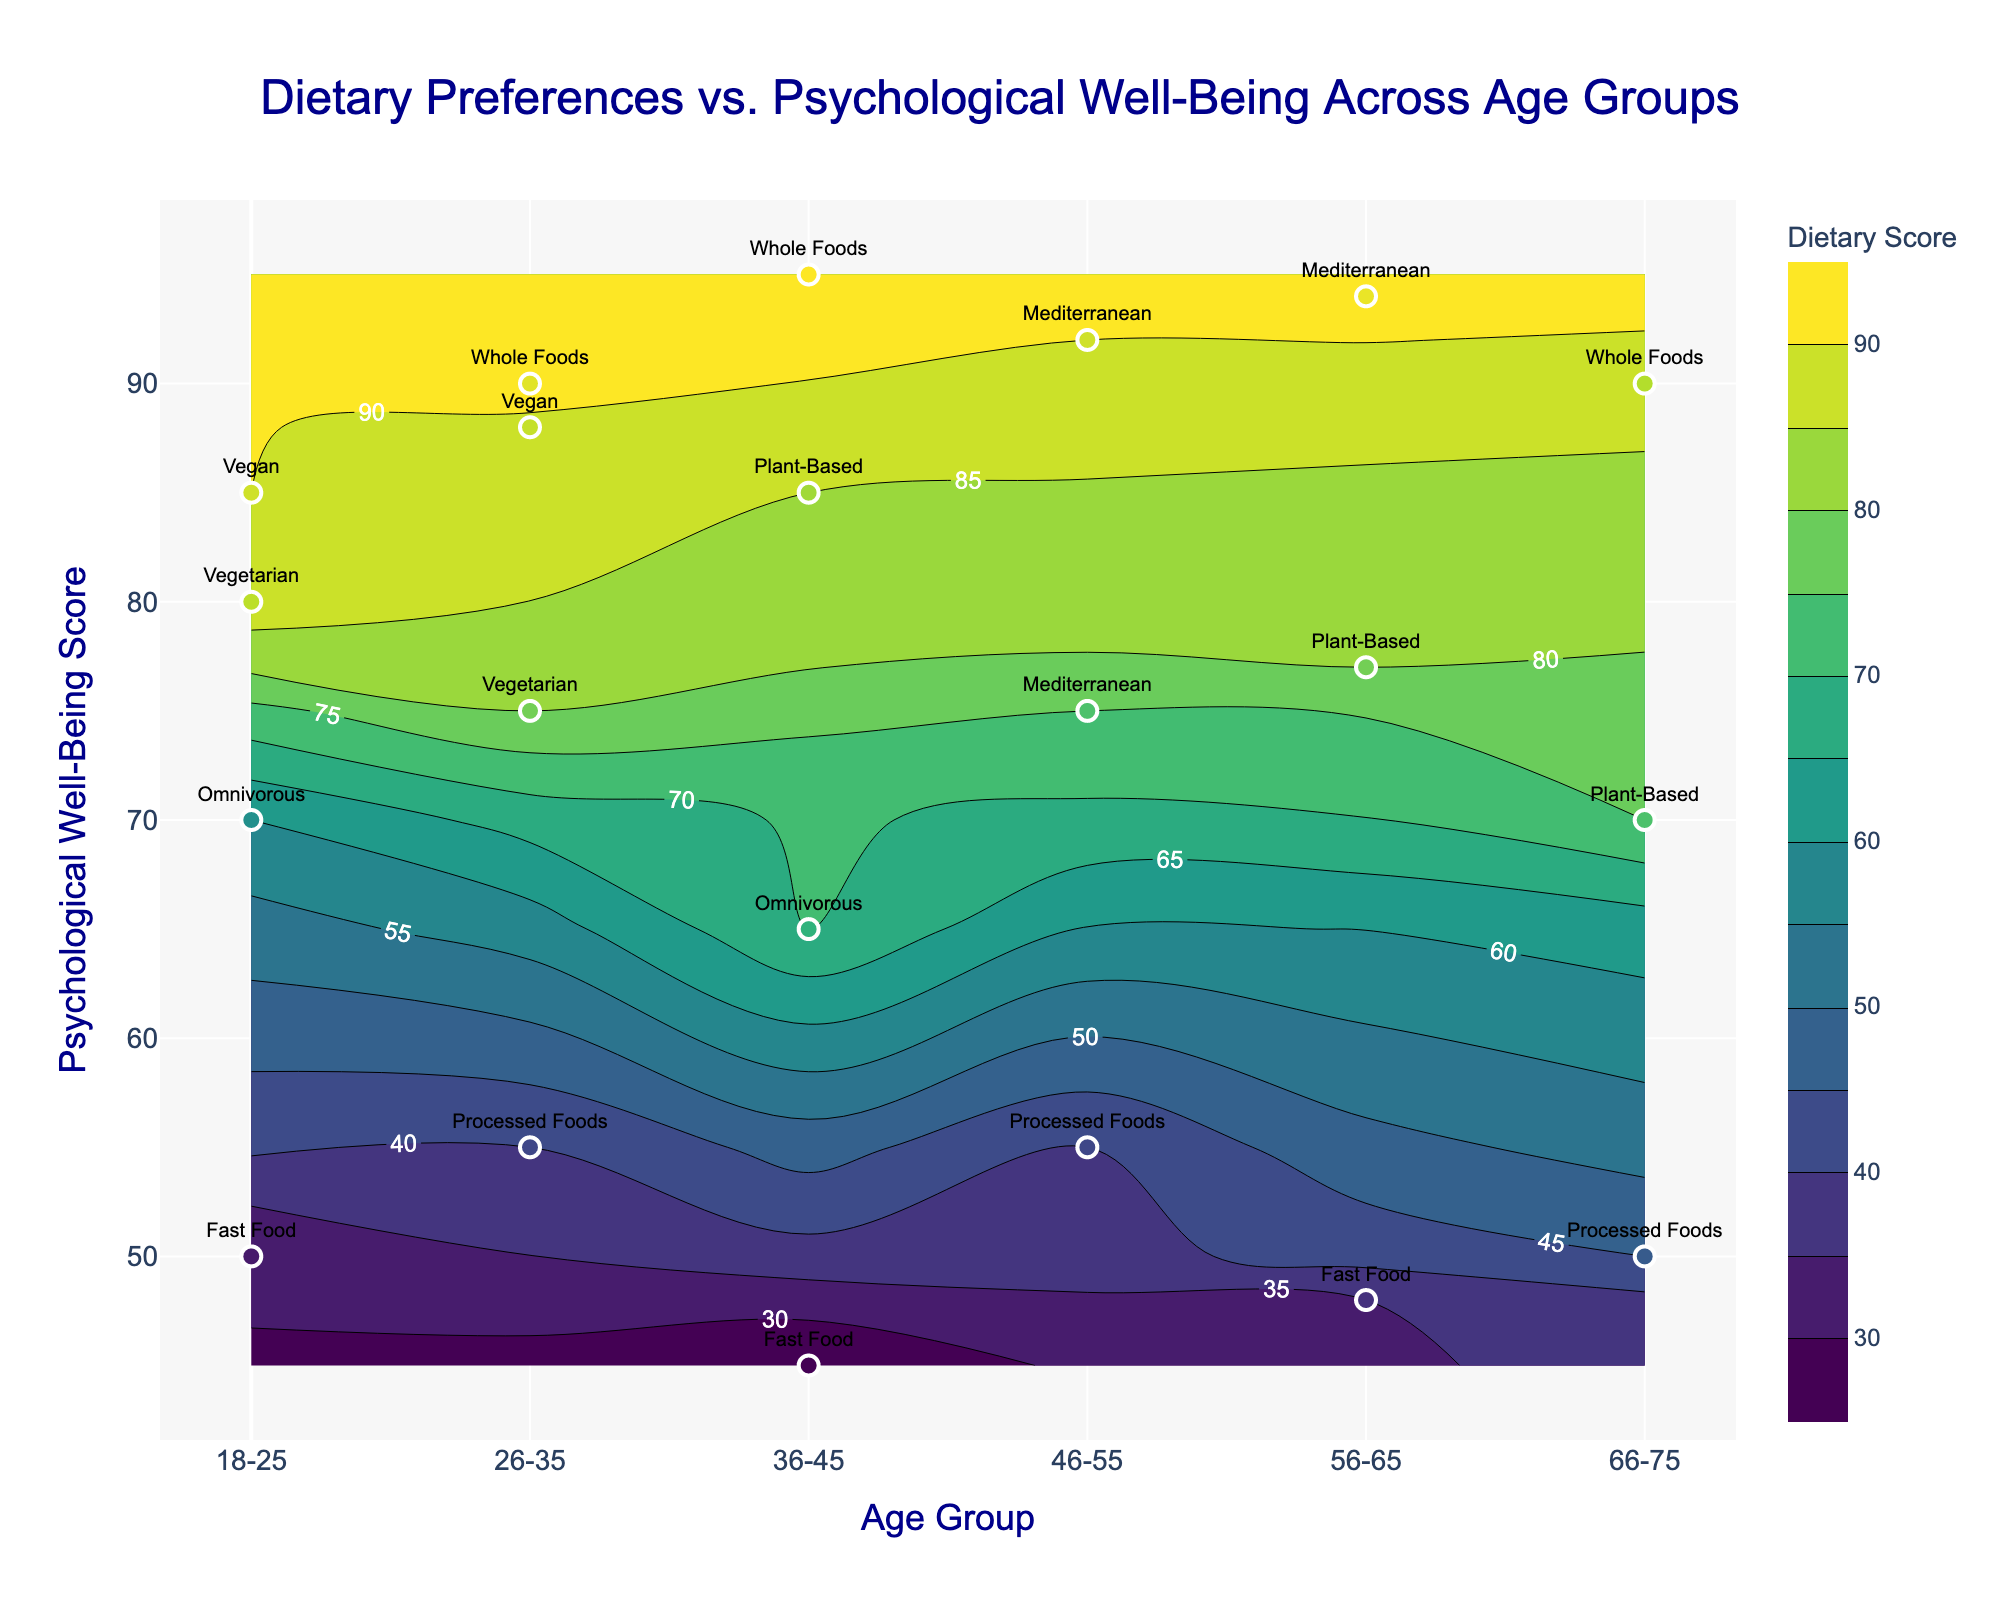What is the title of the plot? The title is visible at the top of the plot and can be directly read from there.
Answer: Dietary Preferences vs. Psychological Well-Being Across Age Groups What are the age groups presented on the x-axis? The x-axis shows categorical labels for age groups. By looking at the tick labels, you can see all the age groups displayed.
Answer: 18-25, 26-35, 36-45, 46-55, 56-65, 66-75 Which dietary preference has the highest "Well-Being Score" for the age group "18-25"? Locate the scatter points for the age group "18-25" on the plot and look for the point with the highest y-coordinate (Well-Being Score). The dietary preference label next to this point is the answer.
Answer: Vegan For the age group "36-45", what is the difference in "Well-Being Score" between those preferring Whole Foods and Fast Food? Identify the y-coordinates (Well-Being Scores) of the dietary preferences Whole Foods and Fast Food for the age group "36-45" and calculate their difference.
Answer: 95 - 45 = 50 Which age group has the highest average Dietary Score? To determine the average Dietary Score for each age group, first sum up the Dietary Scores for each age group, then divide by the number of dietary preferences in that group. Compare these averages across all age groups.
Answer: 56-65 How many dietary preferences are listed for the age group "46-55"? Count the number of scatter points labeled with dietary preferences within the age group "46-55" on the x-axis.
Answer: 3 Is there an age group where a high psychological well-being score correlates with a low dietary score? Scan the plot for points where a high y-coordinate (Well-Being Score) corresponds to a low color intensity (Dietary Score) within a single age group.
Answer: No Which age group has the widest range in "Well-Being Score"? Find the range by subtracting the minimum Well-Being Score from the maximum Well-Being Score for each age group, then identify the age group with the largest result.
Answer: 18-25 Do “Mediterranean” and “Processed Foods” dietary preferences co-occur within any age group? Check each age group for the presence of both “Mediterranean” and “Processed Foods” labels among the scatter points.
Answer: Yes, in age group 46-55 What is the general trend of dietary scores as age groups progress? Observe the contour lines and color gradients as the x-axis value (age group) increases, noting whether the Dietary Scores (color intensities) tend to increase, decrease, or remain constant.
Answer: Generally increasing 